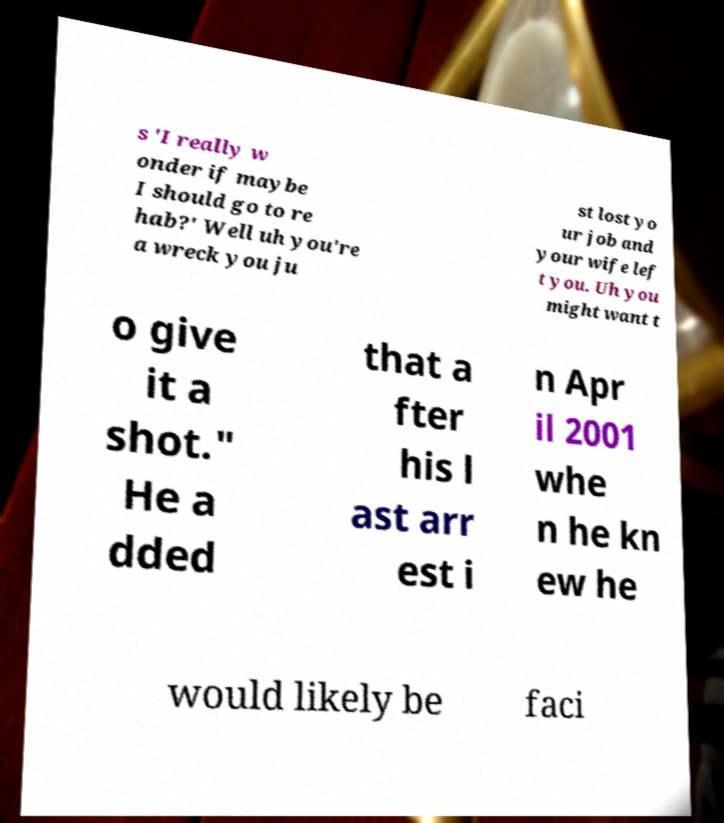I need the written content from this picture converted into text. Can you do that? s 'I really w onder if maybe I should go to re hab?' Well uh you're a wreck you ju st lost yo ur job and your wife lef t you. Uh you might want t o give it a shot." He a dded that a fter his l ast arr est i n Apr il 2001 whe n he kn ew he would likely be faci 